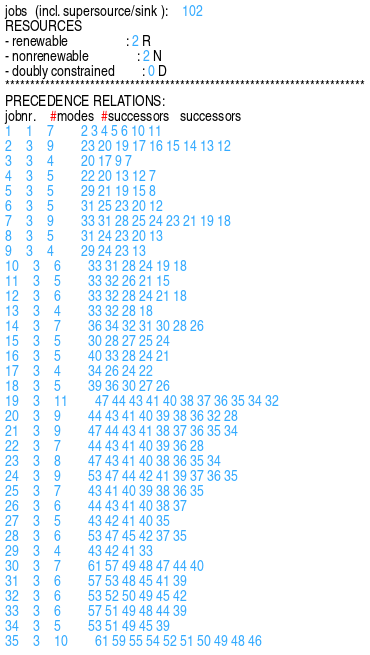Convert code to text. <code><loc_0><loc_0><loc_500><loc_500><_ObjectiveC_>jobs  (incl. supersource/sink ):	102
RESOURCES
- renewable                 : 2 R
- nonrenewable              : 2 N
- doubly constrained        : 0 D
************************************************************************
PRECEDENCE RELATIONS:
jobnr.    #modes  #successors   successors
1	1	7		2 3 4 5 6 10 11 
2	3	9		23 20 19 17 16 15 14 13 12 
3	3	4		20 17 9 7 
4	3	5		22 20 13 12 7 
5	3	5		29 21 19 15 8 
6	3	5		31 25 23 20 12 
7	3	9		33 31 28 25 24 23 21 19 18 
8	3	5		31 24 23 20 13 
9	3	4		29 24 23 13 
10	3	6		33 31 28 24 19 18 
11	3	5		33 32 26 21 15 
12	3	6		33 32 28 24 21 18 
13	3	4		33 32 28 18 
14	3	7		36 34 32 31 30 28 26 
15	3	5		30 28 27 25 24 
16	3	5		40 33 28 24 21 
17	3	4		34 26 24 22 
18	3	5		39 36 30 27 26 
19	3	11		47 44 43 41 40 38 37 36 35 34 32 
20	3	9		44 43 41 40 39 38 36 32 28 
21	3	9		47 44 43 41 38 37 36 35 34 
22	3	7		44 43 41 40 39 36 28 
23	3	8		47 43 41 40 38 36 35 34 
24	3	9		53 47 44 42 41 39 37 36 35 
25	3	7		43 41 40 39 38 36 35 
26	3	6		44 43 41 40 38 37 
27	3	5		43 42 41 40 35 
28	3	6		53 47 45 42 37 35 
29	3	4		43 42 41 33 
30	3	7		61 57 49 48 47 44 40 
31	3	6		57 53 48 45 41 39 
32	3	6		53 52 50 49 45 42 
33	3	6		57 51 49 48 44 39 
34	3	5		53 51 49 45 39 
35	3	10		61 59 55 54 52 51 50 49 48 46 </code> 